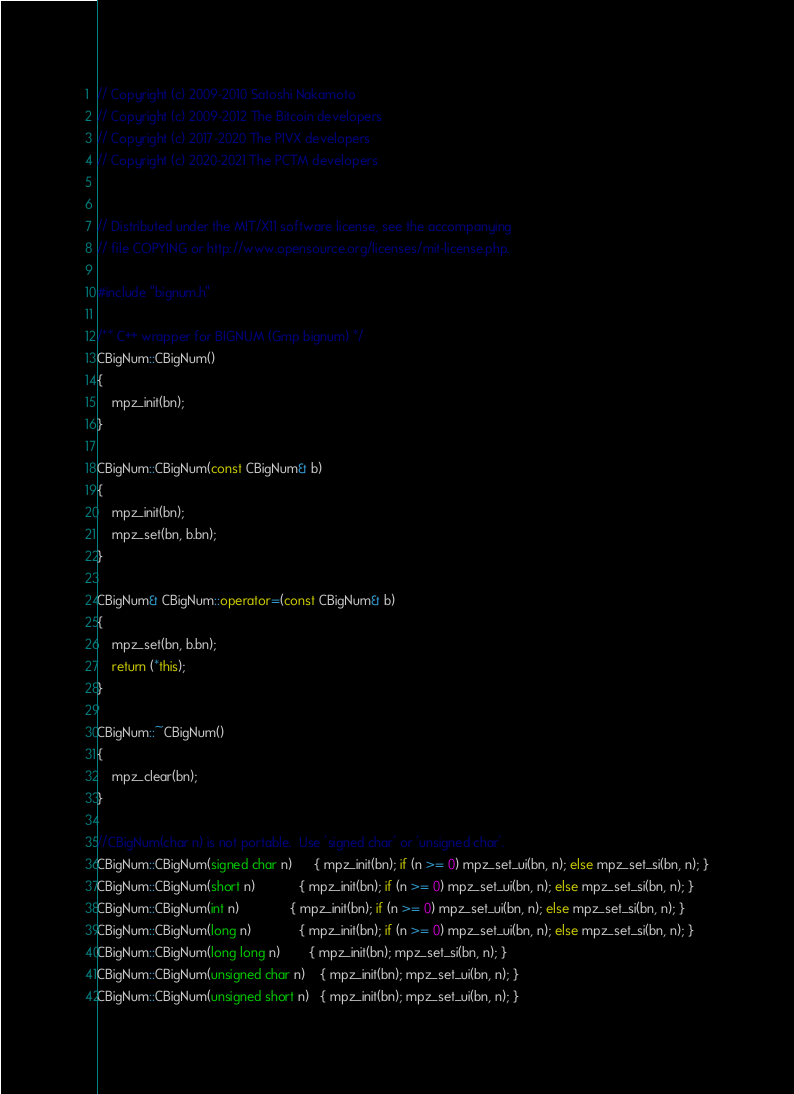<code> <loc_0><loc_0><loc_500><loc_500><_C++_>// Copyright (c) 2009-2010 Satoshi Nakamoto
// Copyright (c) 2009-2012 The Bitcoin developers
// Copyright (c) 2017-2020 The PIVX developers
// Copyright (c) 2020-2021 The PCTM developers


// Distributed under the MIT/X11 software license, see the accompanying
// file COPYING or http://www.opensource.org/licenses/mit-license.php.

#include "bignum.h"

/** C++ wrapper for BIGNUM (Gmp bignum) */
CBigNum::CBigNum()
{
    mpz_init(bn);
}

CBigNum::CBigNum(const CBigNum& b)
{
    mpz_init(bn);
    mpz_set(bn, b.bn);
}

CBigNum& CBigNum::operator=(const CBigNum& b)
{
    mpz_set(bn, b.bn);
    return (*this);
}

CBigNum::~CBigNum()
{
    mpz_clear(bn);
}

//CBigNum(char n) is not portable.  Use 'signed char' or 'unsigned char'.
CBigNum::CBigNum(signed char n)      { mpz_init(bn); if (n >= 0) mpz_set_ui(bn, n); else mpz_set_si(bn, n); }
CBigNum::CBigNum(short n)            { mpz_init(bn); if (n >= 0) mpz_set_ui(bn, n); else mpz_set_si(bn, n); }
CBigNum::CBigNum(int n)              { mpz_init(bn); if (n >= 0) mpz_set_ui(bn, n); else mpz_set_si(bn, n); }
CBigNum::CBigNum(long n)             { mpz_init(bn); if (n >= 0) mpz_set_ui(bn, n); else mpz_set_si(bn, n); }
CBigNum::CBigNum(long long n)        { mpz_init(bn); mpz_set_si(bn, n); }
CBigNum::CBigNum(unsigned char n)    { mpz_init(bn); mpz_set_ui(bn, n); }
CBigNum::CBigNum(unsigned short n)   { mpz_init(bn); mpz_set_ui(bn, n); }</code> 